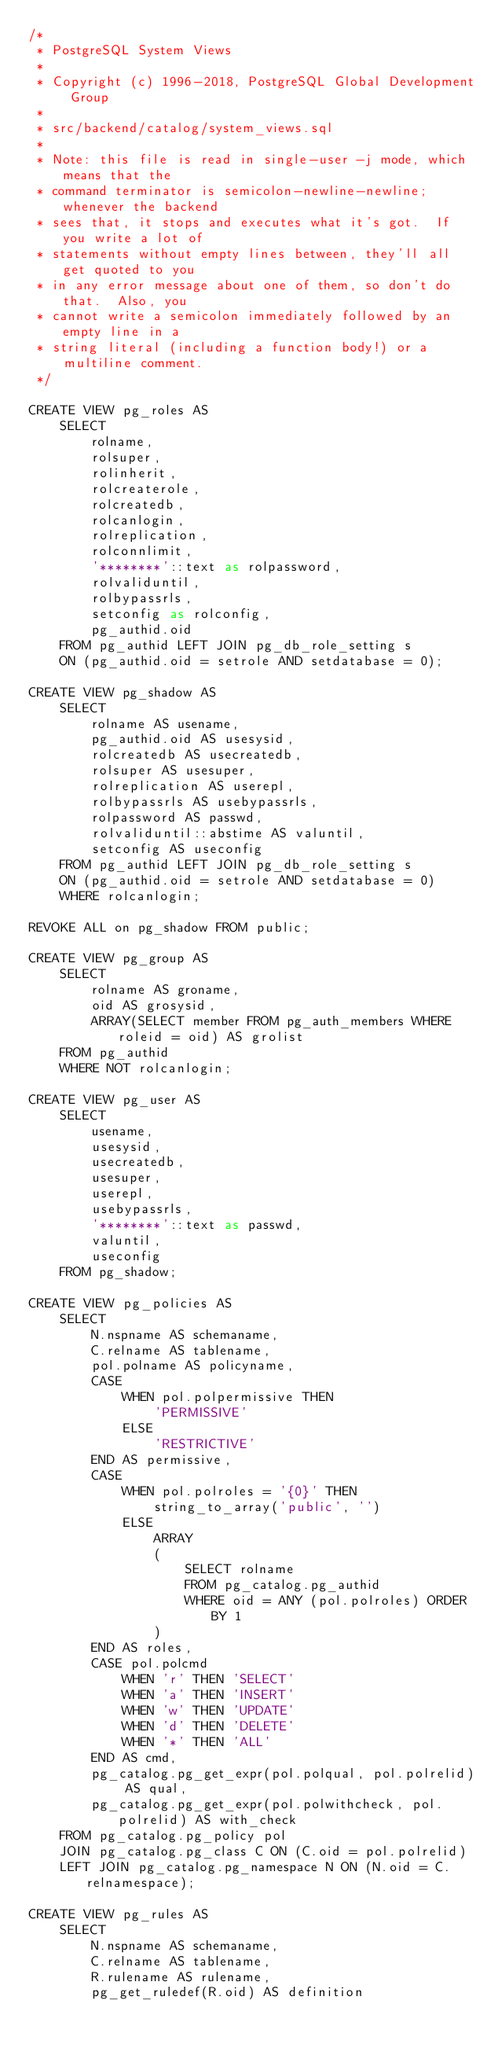<code> <loc_0><loc_0><loc_500><loc_500><_SQL_>/*
 * PostgreSQL System Views
 *
 * Copyright (c) 1996-2018, PostgreSQL Global Development Group
 *
 * src/backend/catalog/system_views.sql
 *
 * Note: this file is read in single-user -j mode, which means that the
 * command terminator is semicolon-newline-newline; whenever the backend
 * sees that, it stops and executes what it's got.  If you write a lot of
 * statements without empty lines between, they'll all get quoted to you
 * in any error message about one of them, so don't do that.  Also, you
 * cannot write a semicolon immediately followed by an empty line in a
 * string literal (including a function body!) or a multiline comment.
 */

CREATE VIEW pg_roles AS
    SELECT
        rolname,
        rolsuper,
        rolinherit,
        rolcreaterole,
        rolcreatedb,
        rolcanlogin,
        rolreplication,
        rolconnlimit,
        '********'::text as rolpassword,
        rolvaliduntil,
        rolbypassrls,
        setconfig as rolconfig,
        pg_authid.oid
    FROM pg_authid LEFT JOIN pg_db_role_setting s
    ON (pg_authid.oid = setrole AND setdatabase = 0);

CREATE VIEW pg_shadow AS
    SELECT
        rolname AS usename,
        pg_authid.oid AS usesysid,
        rolcreatedb AS usecreatedb,
        rolsuper AS usesuper,
        rolreplication AS userepl,
        rolbypassrls AS usebypassrls,
        rolpassword AS passwd,
        rolvaliduntil::abstime AS valuntil,
        setconfig AS useconfig
    FROM pg_authid LEFT JOIN pg_db_role_setting s
    ON (pg_authid.oid = setrole AND setdatabase = 0)
    WHERE rolcanlogin;

REVOKE ALL on pg_shadow FROM public;

CREATE VIEW pg_group AS
    SELECT
        rolname AS groname,
        oid AS grosysid,
        ARRAY(SELECT member FROM pg_auth_members WHERE roleid = oid) AS grolist
    FROM pg_authid
    WHERE NOT rolcanlogin;

CREATE VIEW pg_user AS
    SELECT
        usename,
        usesysid,
        usecreatedb,
        usesuper,
        userepl,
        usebypassrls,
        '********'::text as passwd,
        valuntil,
        useconfig
    FROM pg_shadow;

CREATE VIEW pg_policies AS
    SELECT
        N.nspname AS schemaname,
        C.relname AS tablename,
        pol.polname AS policyname,
        CASE
            WHEN pol.polpermissive THEN
                'PERMISSIVE'
            ELSE
                'RESTRICTIVE'
        END AS permissive,
        CASE
            WHEN pol.polroles = '{0}' THEN
                string_to_array('public', '')
            ELSE
                ARRAY
                (
                    SELECT rolname
                    FROM pg_catalog.pg_authid
                    WHERE oid = ANY (pol.polroles) ORDER BY 1
                )
        END AS roles,
        CASE pol.polcmd
            WHEN 'r' THEN 'SELECT'
            WHEN 'a' THEN 'INSERT'
            WHEN 'w' THEN 'UPDATE'
            WHEN 'd' THEN 'DELETE'
            WHEN '*' THEN 'ALL'
        END AS cmd,
        pg_catalog.pg_get_expr(pol.polqual, pol.polrelid) AS qual,
        pg_catalog.pg_get_expr(pol.polwithcheck, pol.polrelid) AS with_check
    FROM pg_catalog.pg_policy pol
    JOIN pg_catalog.pg_class C ON (C.oid = pol.polrelid)
    LEFT JOIN pg_catalog.pg_namespace N ON (N.oid = C.relnamespace);

CREATE VIEW pg_rules AS
    SELECT
        N.nspname AS schemaname,
        C.relname AS tablename,
        R.rulename AS rulename,
        pg_get_ruledef(R.oid) AS definition</code> 